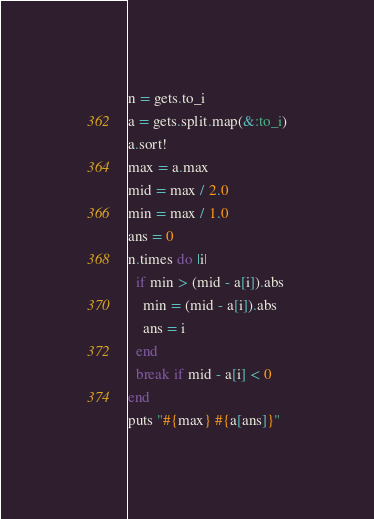Convert code to text. <code><loc_0><loc_0><loc_500><loc_500><_Ruby_>n = gets.to_i
a = gets.split.map(&:to_i)
a.sort!
max = a.max
mid = max / 2.0
min = max / 1.0
ans = 0
n.times do |i|
  if min > (mid - a[i]).abs
    min = (mid - a[i]).abs
    ans = i
  end
  break if mid - a[i] < 0
end
puts "#{max} #{a[ans]}"</code> 